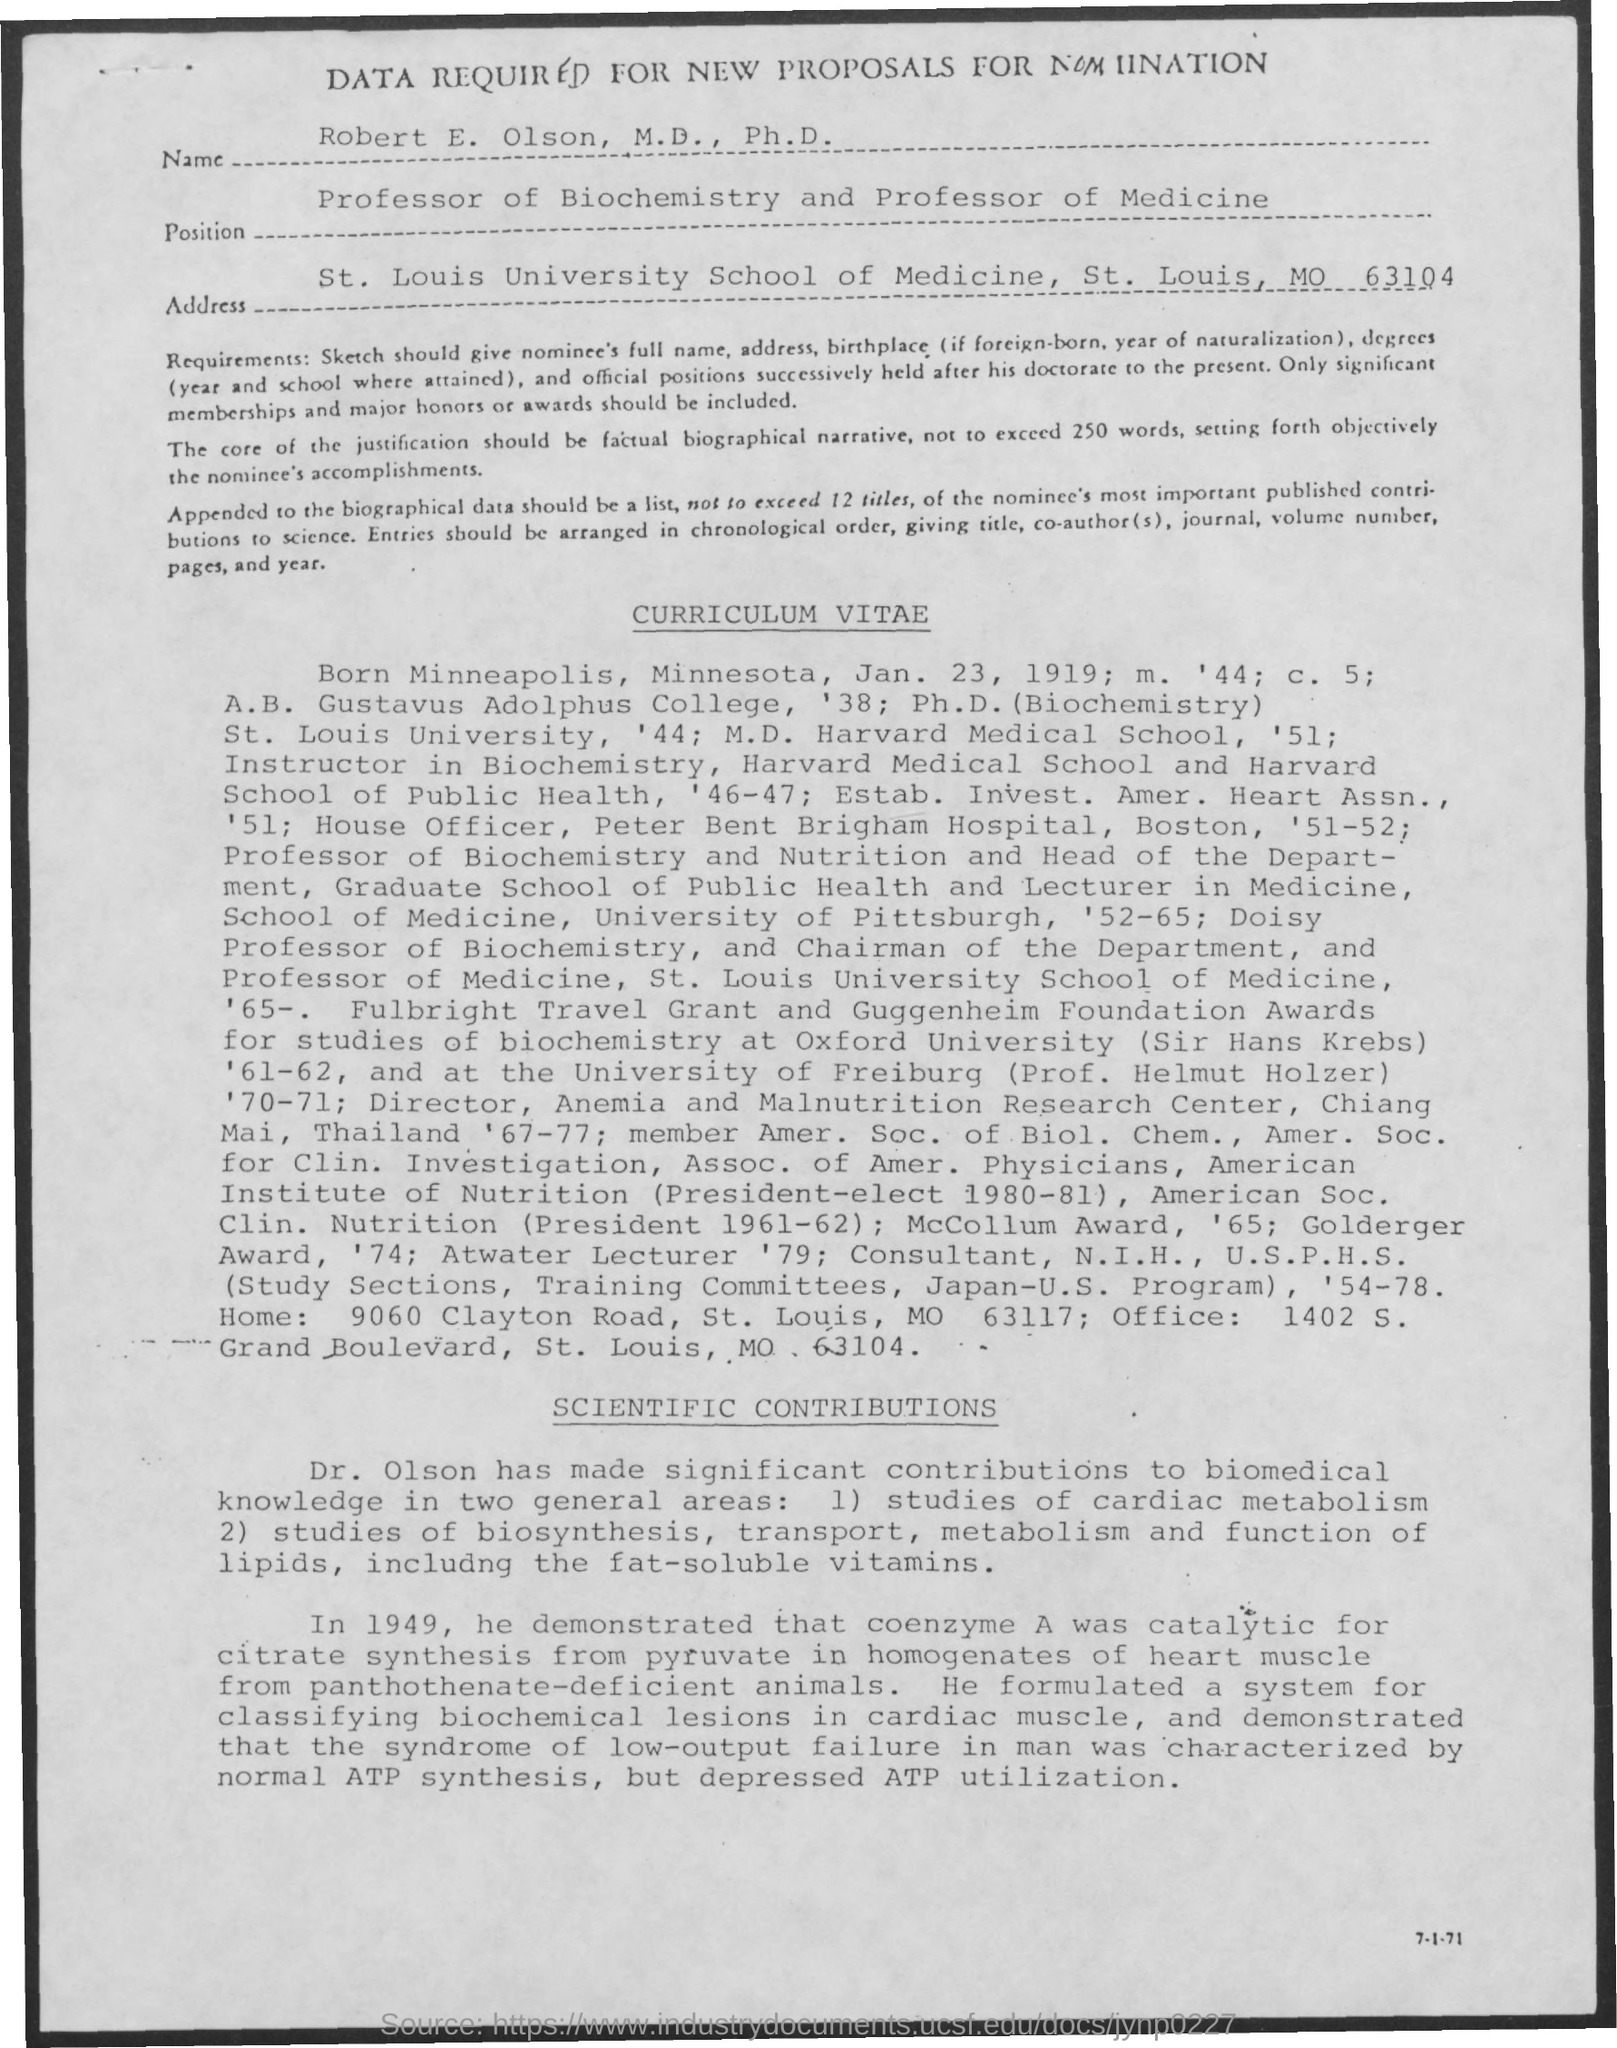Point out several critical features in this image. On January 23, 1919, the curriculum vitae mentioned the date. 